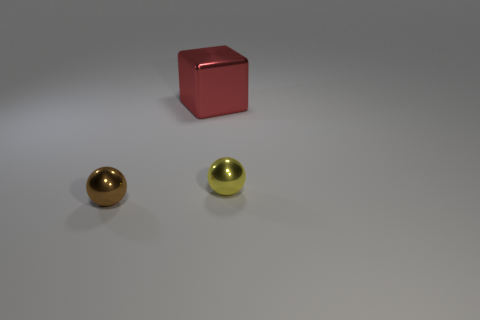What could be the context or purpose of these objects being placed together? The arrangement of these objects might serve several purposes. It could be a simple display of geometric shapes and colors for educational or artistic reasons. It may depict a contrast between the round spheres and the angular cube, or it could be a part of a larger set for a visual effect in photography or design. Another possibility is that these objects are used in a physics demonstration to explore concepts such as reflection, material composition, and the distribution of light on different surfaces. 